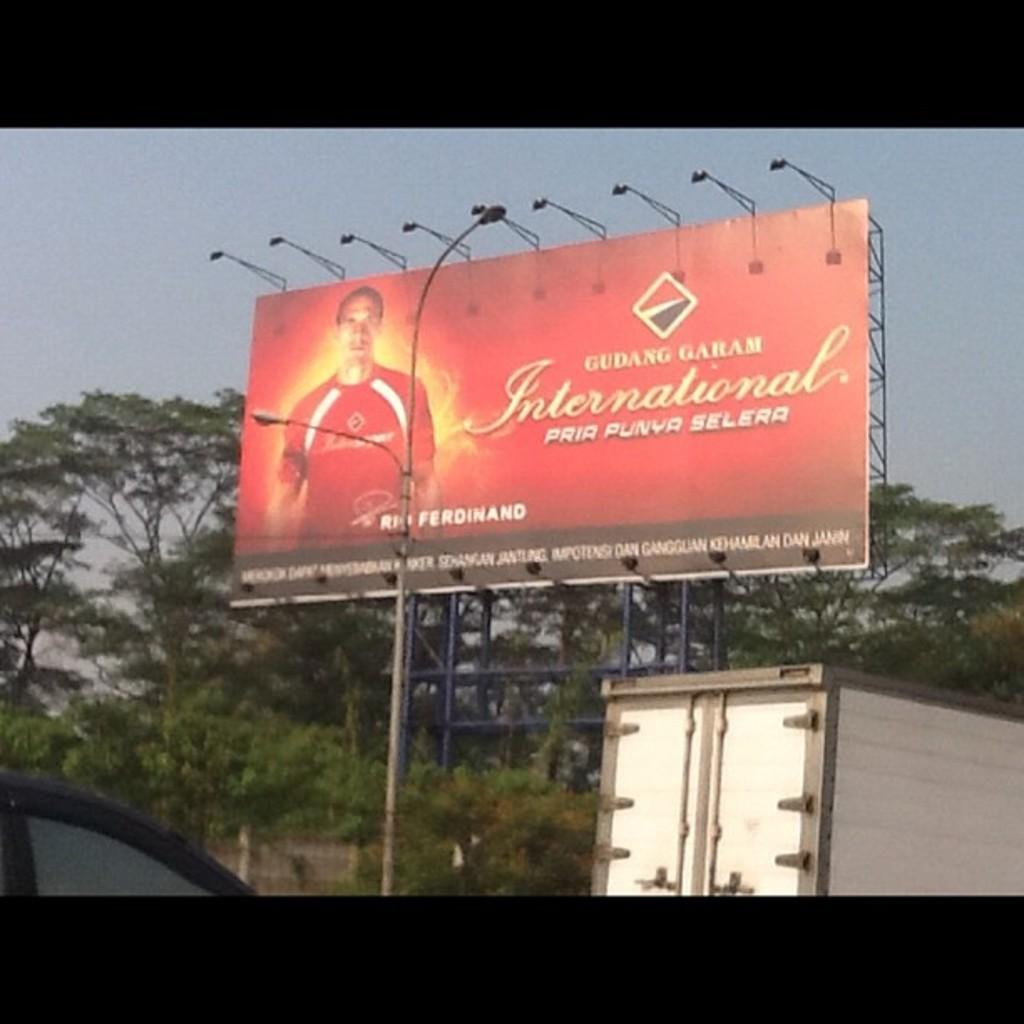<image>
Create a compact narrative representing the image presented. An outdoor billboard in red with a soccer player named Rio Ferdinand on it. 